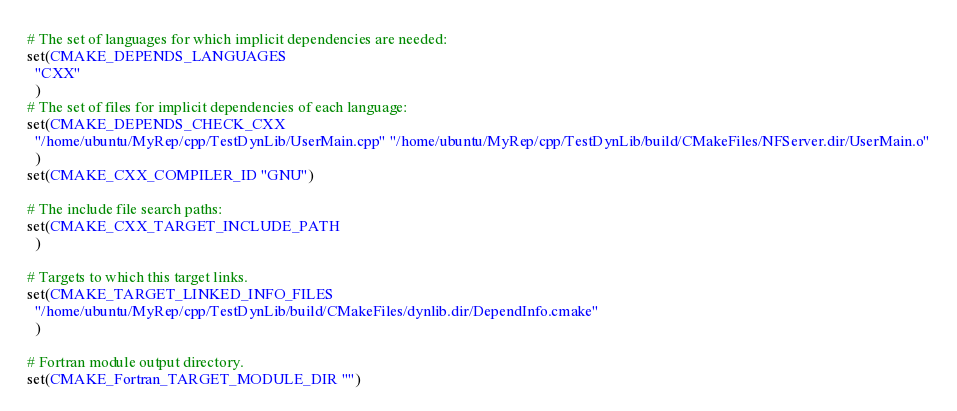<code> <loc_0><loc_0><loc_500><loc_500><_CMake_># The set of languages for which implicit dependencies are needed:
set(CMAKE_DEPENDS_LANGUAGES
  "CXX"
  )
# The set of files for implicit dependencies of each language:
set(CMAKE_DEPENDS_CHECK_CXX
  "/home/ubuntu/MyRep/cpp/TestDynLib/UserMain.cpp" "/home/ubuntu/MyRep/cpp/TestDynLib/build/CMakeFiles/NFServer.dir/UserMain.o"
  )
set(CMAKE_CXX_COMPILER_ID "GNU")

# The include file search paths:
set(CMAKE_CXX_TARGET_INCLUDE_PATH
  )

# Targets to which this target links.
set(CMAKE_TARGET_LINKED_INFO_FILES
  "/home/ubuntu/MyRep/cpp/TestDynLib/build/CMakeFiles/dynlib.dir/DependInfo.cmake"
  )

# Fortran module output directory.
set(CMAKE_Fortran_TARGET_MODULE_DIR "")
</code> 